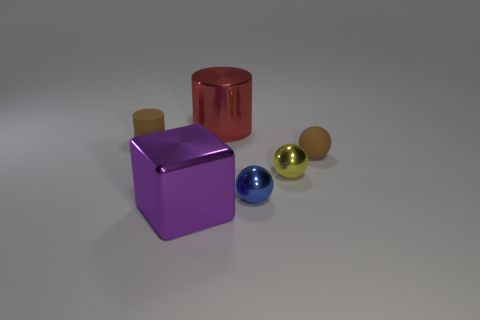Add 3 brown matte cylinders. How many objects exist? 9 Subtract all blocks. How many objects are left? 5 Subtract 0 gray cylinders. How many objects are left? 6 Subtract all large cubes. Subtract all purple shiny cubes. How many objects are left? 4 Add 2 blue metallic balls. How many blue metallic balls are left? 3 Add 1 large gray matte cubes. How many large gray matte cubes exist? 1 